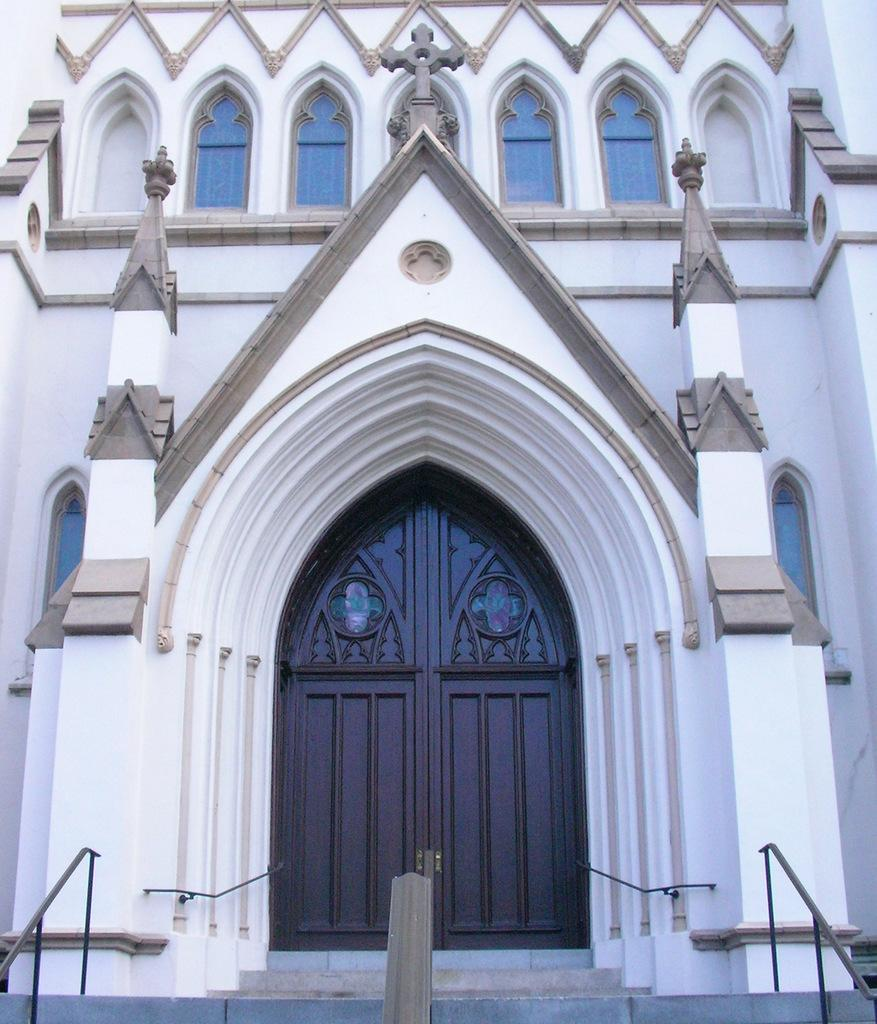What type of structure is present in the image? There is a building in the image. What colors are used for the building? The building is in white and cream colors. What is the entrance to the building like? There is a door in front of the building. What is the color of the door? The door is in brown color. How can one access the building? There are stairs in front of the building. Is there any additional feature for safety or support? Yes, there is a railing visible in the image. What type of soup is being served in the image? There is no soup present in the image; it features a building with a door, stairs, and a railing. 